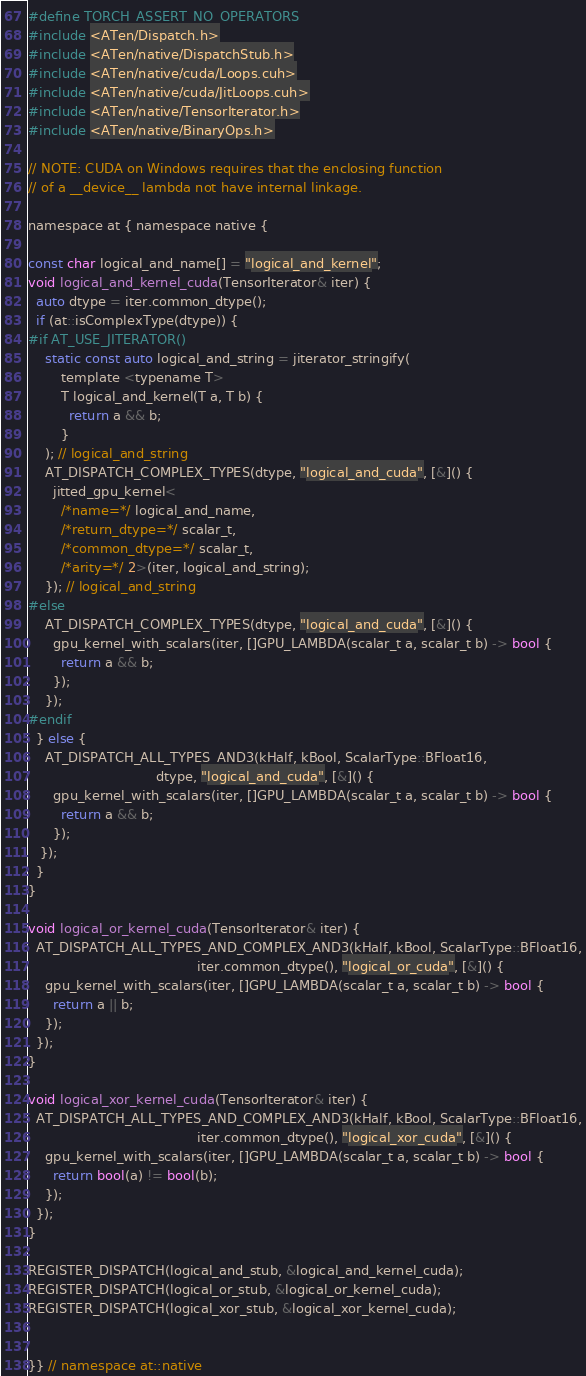<code> <loc_0><loc_0><loc_500><loc_500><_Cuda_>#define TORCH_ASSERT_NO_OPERATORS
#include <ATen/Dispatch.h>
#include <ATen/native/DispatchStub.h>
#include <ATen/native/cuda/Loops.cuh>
#include <ATen/native/cuda/JitLoops.cuh>
#include <ATen/native/TensorIterator.h>
#include <ATen/native/BinaryOps.h>

// NOTE: CUDA on Windows requires that the enclosing function
// of a __device__ lambda not have internal linkage.

namespace at { namespace native {

const char logical_and_name[] = "logical_and_kernel";
void logical_and_kernel_cuda(TensorIterator& iter) {
  auto dtype = iter.common_dtype();
  if (at::isComplexType(dtype)) {
#if AT_USE_JITERATOR()
    static const auto logical_and_string = jiterator_stringify(
        template <typename T>
        T logical_and_kernel(T a, T b) {
          return a && b;
        }
    ); // logical_and_string
    AT_DISPATCH_COMPLEX_TYPES(dtype, "logical_and_cuda", [&]() {
      jitted_gpu_kernel<
        /*name=*/ logical_and_name,
        /*return_dtype=*/ scalar_t,
        /*common_dtype=*/ scalar_t,
        /*arity=*/ 2>(iter, logical_and_string);
    }); // logical_and_string
#else
    AT_DISPATCH_COMPLEX_TYPES(dtype, "logical_and_cuda", [&]() {
      gpu_kernel_with_scalars(iter, []GPU_LAMBDA(scalar_t a, scalar_t b) -> bool {
        return a && b;
      });
    });
#endif
  } else {
    AT_DISPATCH_ALL_TYPES_AND3(kHalf, kBool, ScalarType::BFloat16,
                               dtype, "logical_and_cuda", [&]() {
      gpu_kernel_with_scalars(iter, []GPU_LAMBDA(scalar_t a, scalar_t b) -> bool {
        return a && b;
      });
   });
  }
}

void logical_or_kernel_cuda(TensorIterator& iter) {
  AT_DISPATCH_ALL_TYPES_AND_COMPLEX_AND3(kHalf, kBool, ScalarType::BFloat16,
                                         iter.common_dtype(), "logical_or_cuda", [&]() {
    gpu_kernel_with_scalars(iter, []GPU_LAMBDA(scalar_t a, scalar_t b) -> bool {
      return a || b;
    });
  });
}

void logical_xor_kernel_cuda(TensorIterator& iter) {
  AT_DISPATCH_ALL_TYPES_AND_COMPLEX_AND3(kHalf, kBool, ScalarType::BFloat16,
                                         iter.common_dtype(), "logical_xor_cuda", [&]() {
    gpu_kernel_with_scalars(iter, []GPU_LAMBDA(scalar_t a, scalar_t b) -> bool {
      return bool(a) != bool(b);
    });
  });
}

REGISTER_DISPATCH(logical_and_stub, &logical_and_kernel_cuda);
REGISTER_DISPATCH(logical_or_stub, &logical_or_kernel_cuda);
REGISTER_DISPATCH(logical_xor_stub, &logical_xor_kernel_cuda);


}} // namespace at::native
</code> 